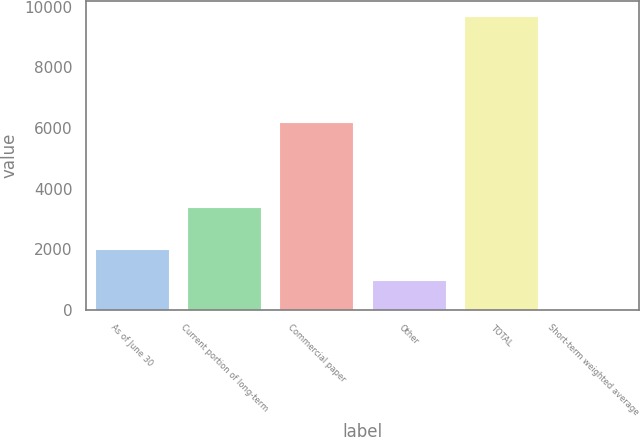Convert chart. <chart><loc_0><loc_0><loc_500><loc_500><bar_chart><fcel>As of June 30<fcel>Current portion of long-term<fcel>Commercial paper<fcel>Other<fcel>TOTAL<fcel>Short-term weighted average<nl><fcel>2019<fcel>3388<fcel>6183<fcel>970.15<fcel>9697<fcel>0.5<nl></chart> 